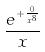<formula> <loc_0><loc_0><loc_500><loc_500>\frac { e ^ { + \frac { 0 } { x ^ { 8 } } } } { x }</formula> 